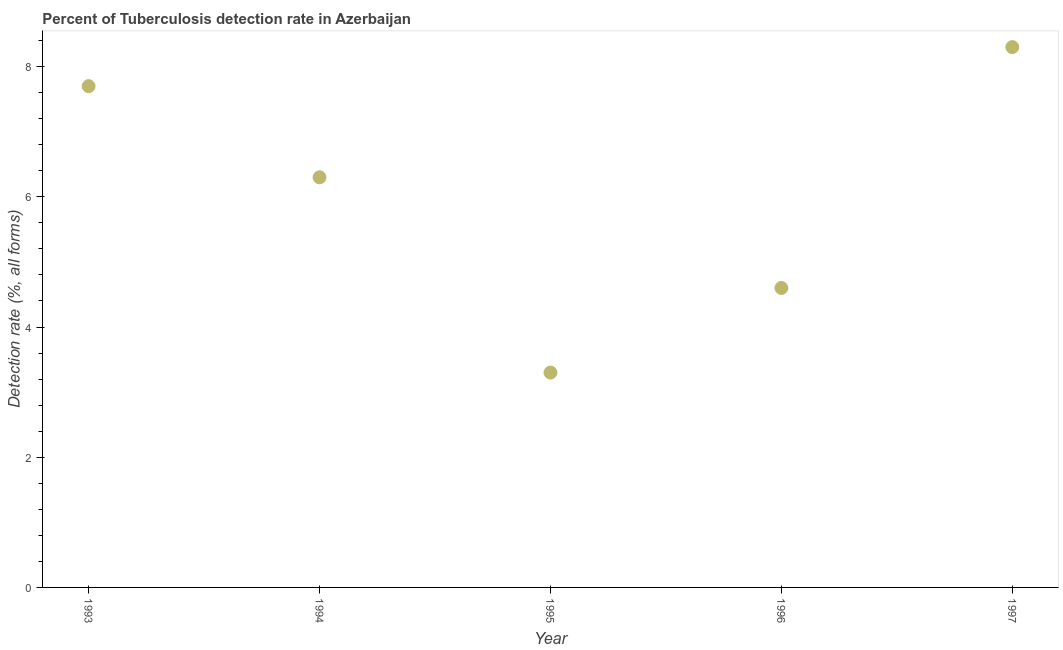What is the detection rate of tuberculosis in 1996?
Provide a short and direct response. 4.6. Across all years, what is the maximum detection rate of tuberculosis?
Provide a short and direct response. 8.3. In which year was the detection rate of tuberculosis maximum?
Your answer should be compact. 1997. What is the sum of the detection rate of tuberculosis?
Offer a very short reply. 30.2. What is the difference between the detection rate of tuberculosis in 1994 and 1997?
Keep it short and to the point. -2. What is the average detection rate of tuberculosis per year?
Your response must be concise. 6.04. What is the median detection rate of tuberculosis?
Your answer should be compact. 6.3. In how many years, is the detection rate of tuberculosis greater than 2 %?
Provide a succinct answer. 5. What is the ratio of the detection rate of tuberculosis in 1995 to that in 1997?
Provide a succinct answer. 0.4. Is the detection rate of tuberculosis in 1995 less than that in 1997?
Give a very brief answer. Yes. Is the difference between the detection rate of tuberculosis in 1993 and 1995 greater than the difference between any two years?
Your answer should be very brief. No. What is the difference between the highest and the second highest detection rate of tuberculosis?
Offer a very short reply. 0.6. Is the sum of the detection rate of tuberculosis in 1993 and 1997 greater than the maximum detection rate of tuberculosis across all years?
Offer a very short reply. Yes. What is the difference between the highest and the lowest detection rate of tuberculosis?
Ensure brevity in your answer.  5. Does the detection rate of tuberculosis monotonically increase over the years?
Give a very brief answer. No. What is the difference between two consecutive major ticks on the Y-axis?
Provide a short and direct response. 2. Does the graph contain any zero values?
Give a very brief answer. No. What is the title of the graph?
Provide a short and direct response. Percent of Tuberculosis detection rate in Azerbaijan. What is the label or title of the X-axis?
Make the answer very short. Year. What is the label or title of the Y-axis?
Give a very brief answer. Detection rate (%, all forms). What is the Detection rate (%, all forms) in 1994?
Your response must be concise. 6.3. What is the Detection rate (%, all forms) in 1997?
Your answer should be compact. 8.3. What is the difference between the Detection rate (%, all forms) in 1993 and 1994?
Offer a very short reply. 1.4. What is the difference between the Detection rate (%, all forms) in 1993 and 1996?
Offer a terse response. 3.1. What is the difference between the Detection rate (%, all forms) in 1994 and 1996?
Ensure brevity in your answer.  1.7. What is the difference between the Detection rate (%, all forms) in 1995 and 1996?
Your response must be concise. -1.3. What is the difference between the Detection rate (%, all forms) in 1995 and 1997?
Give a very brief answer. -5. What is the ratio of the Detection rate (%, all forms) in 1993 to that in 1994?
Give a very brief answer. 1.22. What is the ratio of the Detection rate (%, all forms) in 1993 to that in 1995?
Keep it short and to the point. 2.33. What is the ratio of the Detection rate (%, all forms) in 1993 to that in 1996?
Provide a short and direct response. 1.67. What is the ratio of the Detection rate (%, all forms) in 1993 to that in 1997?
Give a very brief answer. 0.93. What is the ratio of the Detection rate (%, all forms) in 1994 to that in 1995?
Offer a very short reply. 1.91. What is the ratio of the Detection rate (%, all forms) in 1994 to that in 1996?
Offer a terse response. 1.37. What is the ratio of the Detection rate (%, all forms) in 1994 to that in 1997?
Keep it short and to the point. 0.76. What is the ratio of the Detection rate (%, all forms) in 1995 to that in 1996?
Your answer should be compact. 0.72. What is the ratio of the Detection rate (%, all forms) in 1995 to that in 1997?
Ensure brevity in your answer.  0.4. What is the ratio of the Detection rate (%, all forms) in 1996 to that in 1997?
Ensure brevity in your answer.  0.55. 